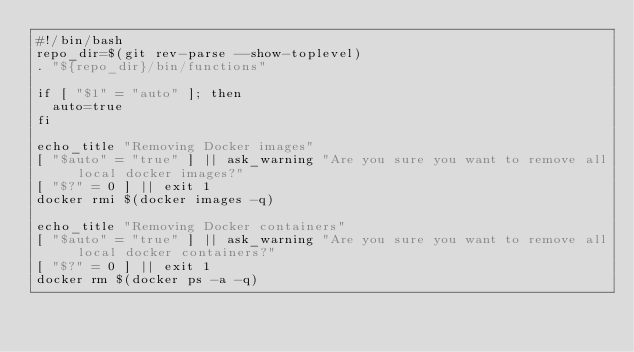Convert code to text. <code><loc_0><loc_0><loc_500><loc_500><_Bash_>#!/bin/bash
repo_dir=$(git rev-parse --show-toplevel)
. "${repo_dir}/bin/functions"

if [ "$1" = "auto" ]; then
  auto=true
fi

echo_title "Removing Docker images"
[ "$auto" = "true" ] || ask_warning "Are you sure you want to remove all local docker images?"
[ "$?" = 0 ] || exit 1
docker rmi $(docker images -q)

echo_title "Removing Docker containers"
[ "$auto" = "true" ] || ask_warning "Are you sure you want to remove all local docker containers?"
[ "$?" = 0 ] || exit 1
docker rm $(docker ps -a -q)

</code> 